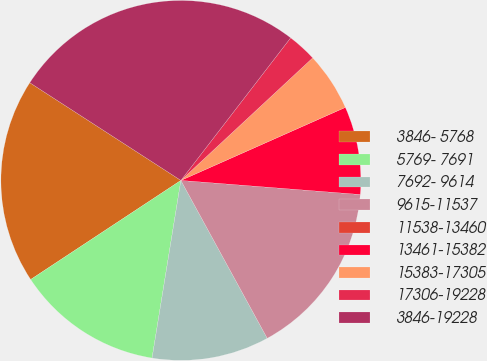Convert chart to OTSL. <chart><loc_0><loc_0><loc_500><loc_500><pie_chart><fcel>3846- 5768<fcel>5769- 7691<fcel>7692- 9614<fcel>9615-11537<fcel>11538-13460<fcel>13461-15382<fcel>15383-17305<fcel>17306-19228<fcel>3846-19228<nl><fcel>18.42%<fcel>13.16%<fcel>10.53%<fcel>15.79%<fcel>0.0%<fcel>7.9%<fcel>5.27%<fcel>2.64%<fcel>26.31%<nl></chart> 